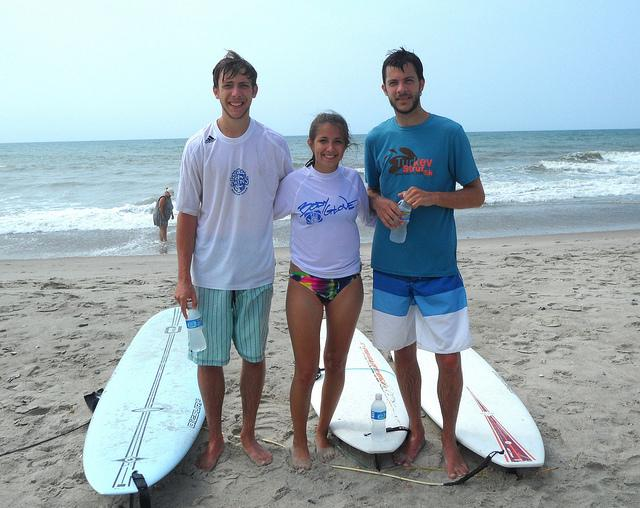How many types of surfboards are there? Please explain your reasoning. three. There are three surfboards for each person shown. 